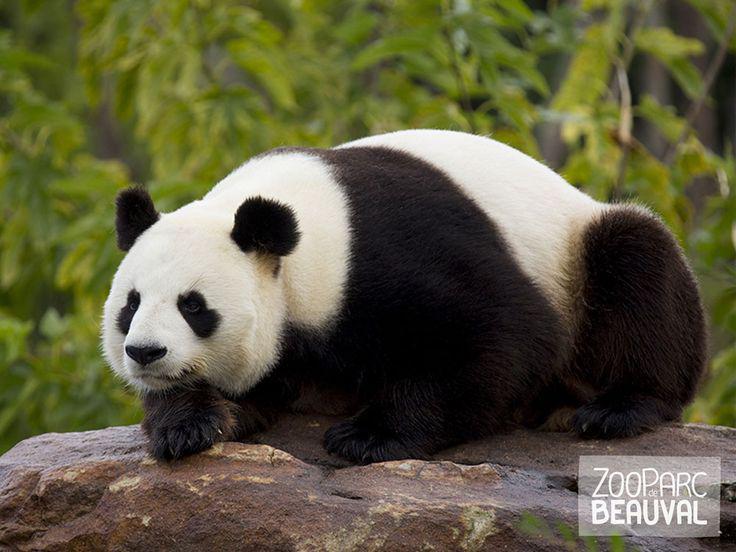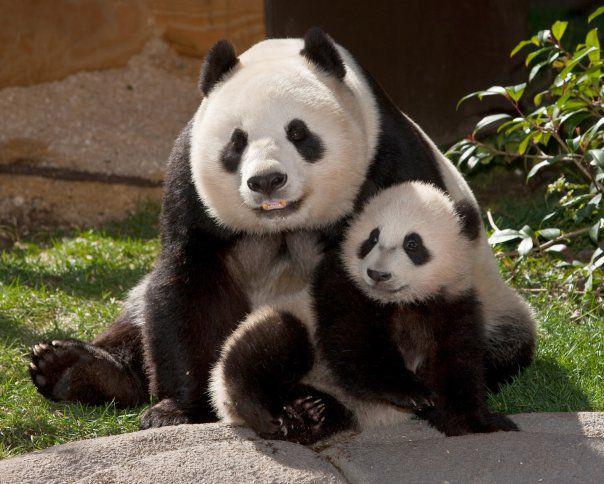The first image is the image on the left, the second image is the image on the right. Evaluate the accuracy of this statement regarding the images: "In one image, an adult panda is sitting upright with a baby panda sitting beside her.". Is it true? Answer yes or no. Yes. 